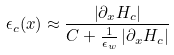Convert formula to latex. <formula><loc_0><loc_0><loc_500><loc_500>\epsilon _ { c } ( x ) \approx \frac { \left | \partial _ { x } H _ { c } \right | } { C + \frac { 1 } { \epsilon _ { w } } \left | \partial _ { x } H _ { c } \right | }</formula> 